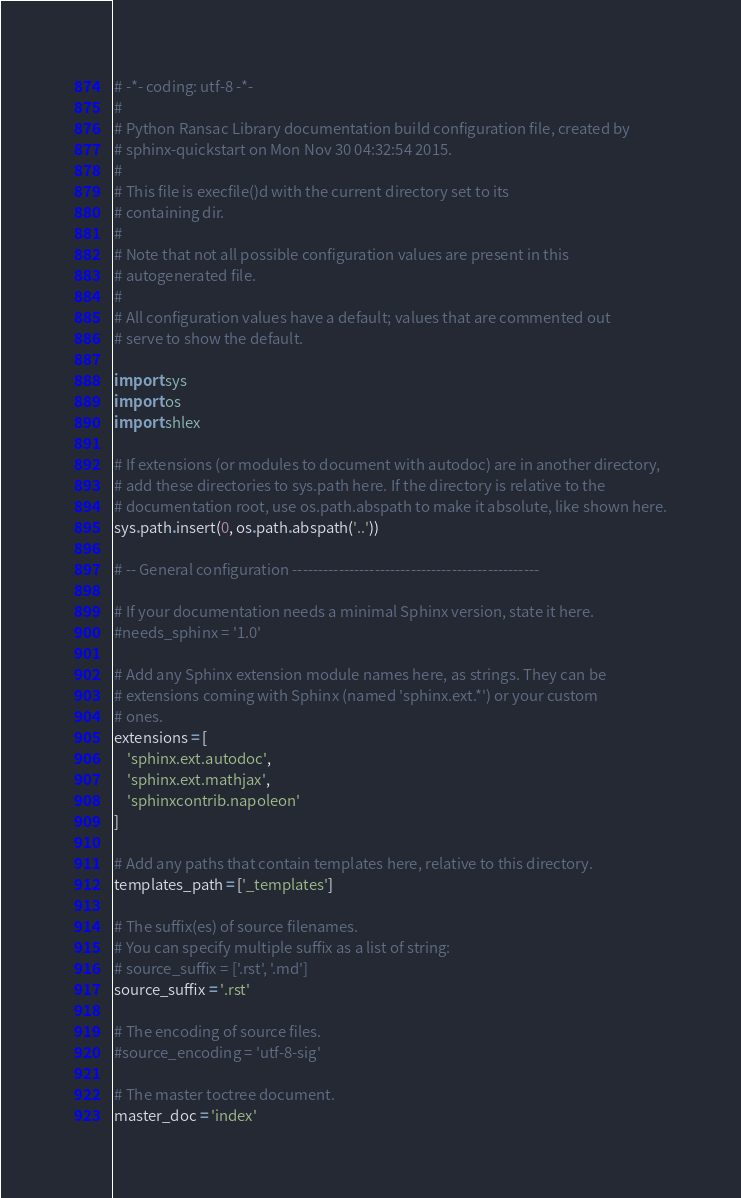<code> <loc_0><loc_0><loc_500><loc_500><_Python_># -*- coding: utf-8 -*-
#
# Python Ransac Library documentation build configuration file, created by
# sphinx-quickstart on Mon Nov 30 04:32:54 2015.
#
# This file is execfile()d with the current directory set to its
# containing dir.
#
# Note that not all possible configuration values are present in this
# autogenerated file.
#
# All configuration values have a default; values that are commented out
# serve to show the default.

import sys
import os
import shlex

# If extensions (or modules to document with autodoc) are in another directory,
# add these directories to sys.path here. If the directory is relative to the
# documentation root, use os.path.abspath to make it absolute, like shown here.
sys.path.insert(0, os.path.abspath('..'))

# -- General configuration ------------------------------------------------

# If your documentation needs a minimal Sphinx version, state it here.
#needs_sphinx = '1.0'

# Add any Sphinx extension module names here, as strings. They can be
# extensions coming with Sphinx (named 'sphinx.ext.*') or your custom
# ones.
extensions = [
    'sphinx.ext.autodoc',
    'sphinx.ext.mathjax',
    'sphinxcontrib.napoleon'
]

# Add any paths that contain templates here, relative to this directory.
templates_path = ['_templates']

# The suffix(es) of source filenames.
# You can specify multiple suffix as a list of string:
# source_suffix = ['.rst', '.md']
source_suffix = '.rst'

# The encoding of source files.
#source_encoding = 'utf-8-sig'

# The master toctree document.
master_doc = 'index'
</code> 